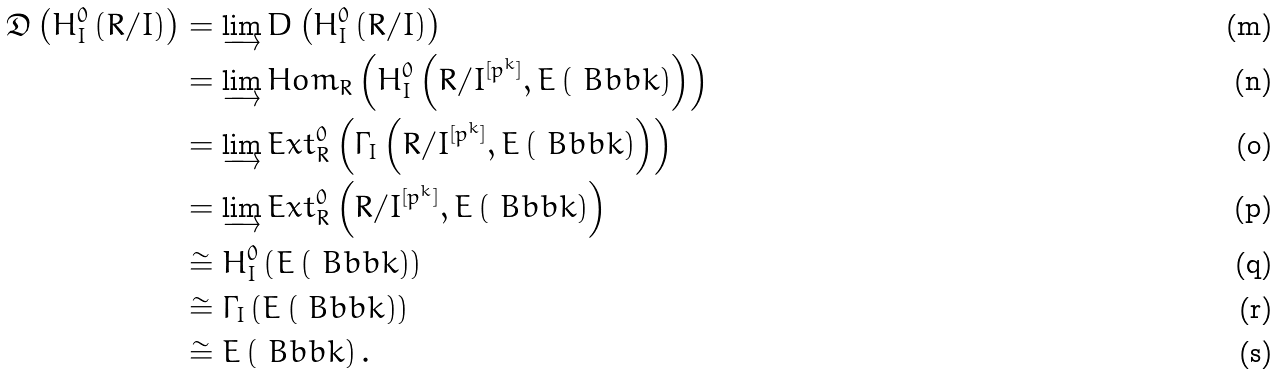<formula> <loc_0><loc_0><loc_500><loc_500>\mathfrak { D } \left ( H _ { I } ^ { 0 } \left ( R / I \right ) \right ) & = \varinjlim D \left ( H _ { I } ^ { 0 } \left ( R / I \right ) \right ) \\ & = \varinjlim H o m _ { R } \left ( H _ { I } ^ { 0 } \left ( R / I ^ { [ p ^ { k } ] } , E \left ( \ B b b k \right ) \right ) \right ) \\ & = \varinjlim E x t ^ { 0 } _ { R } \left ( \Gamma _ { I } \left ( R / I ^ { [ p ^ { k } ] } , E \left ( \ B b b k \right ) \right ) \right ) \\ & = \varinjlim E x t ^ { 0 } _ { R } \left ( R / I ^ { [ p ^ { k } ] } , E \left ( \ B b b k \right ) \right ) \\ & \cong H _ { I } ^ { 0 } \left ( E \left ( \ B b b k \right ) \right ) \\ & \cong \Gamma _ { I } \left ( E \left ( \ B b b k \right ) \right ) \\ & \cong E \left ( \ B b b k \right ) .</formula> 